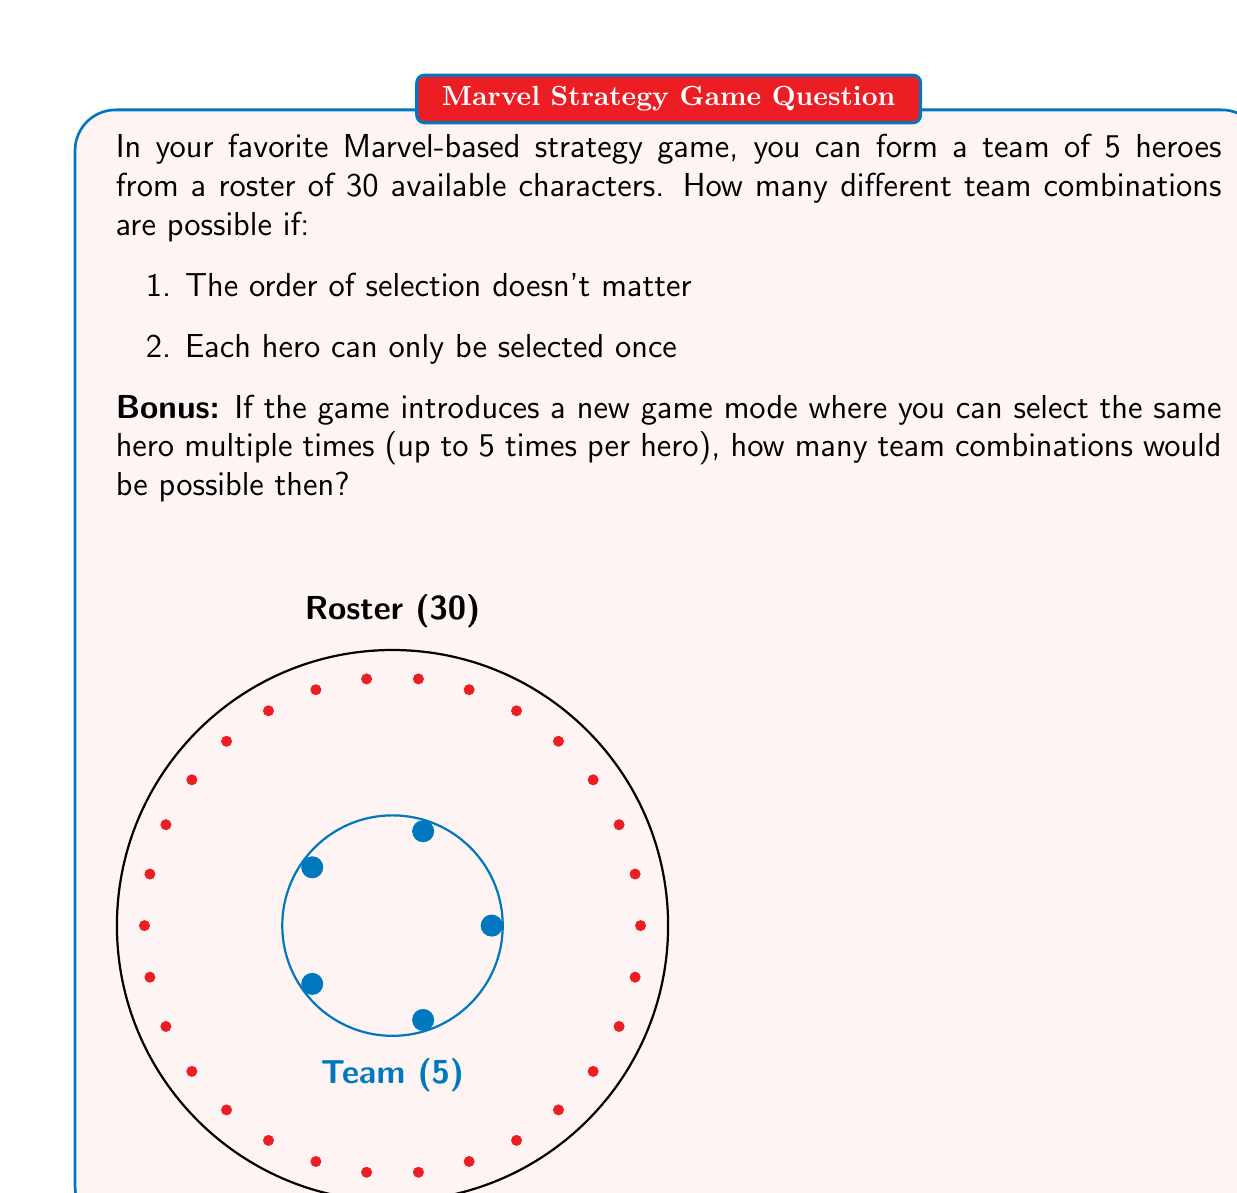Could you help me with this problem? Let's approach this step-by-step:

1) For the main question, we're dealing with a combination problem. We want to choose 5 heroes from a pool of 30, where the order doesn't matter and repetition is not allowed.

   This is a perfect scenario for using the combination formula:

   $$C(n,r) = \frac{n!}{r!(n-r)!}$$

   Where $n$ is the total number of items to choose from, and $r$ is the number of items being chosen.

2) In this case, $n = 30$ (total heroes) and $r = 5$ (team size).

3) Plugging these numbers into our formula:

   $$C(30,5) = \frac{30!}{5!(30-5)!} = \frac{30!}{5!25!}$$

4) Calculating this:
   
   $$\frac{30!}{5!25!} = 142,506$$

5) For the bonus question, we're now dealing with a scenario where repetition is allowed. This changes our approach from combinations to combinations with repetition.

6) The formula for combinations with repetition is:

   $$C_R(n,r) = \frac{(n+r-1)!}{r!(n-1)!}$$

7) In this case, $n$ is still 30, and $r$ is still 5.

8) Plugging these numbers into our new formula:

   $$C_R(30,5) = \frac{(30+5-1)!}{5!(30-1)!} = \frac{34!}{5!29!}$$

9) Calculating this:
   
   $$\frac{34!}{5!29!} = 324,632$$

Thus, allowing repetition significantly increases the number of possible team combinations.
Answer: 142,506 combinations; With repetition: 324,632 combinations 